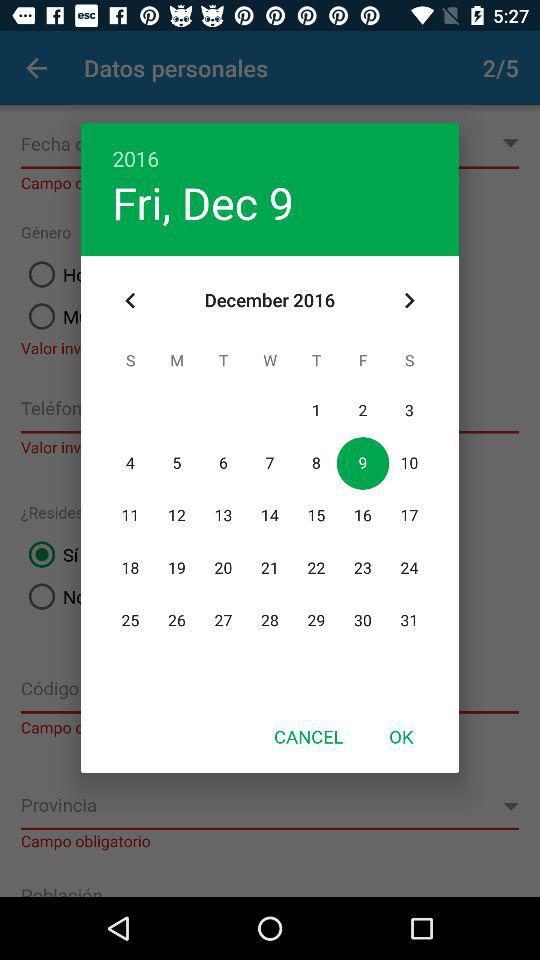What day is December 2? December 2 is Friday. 